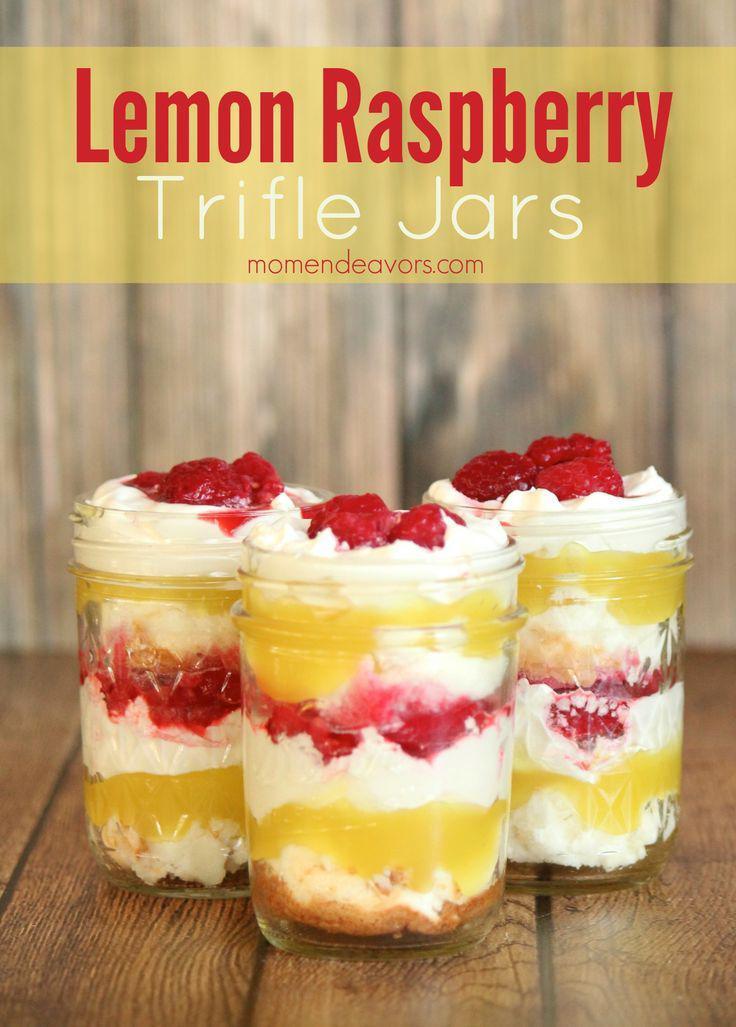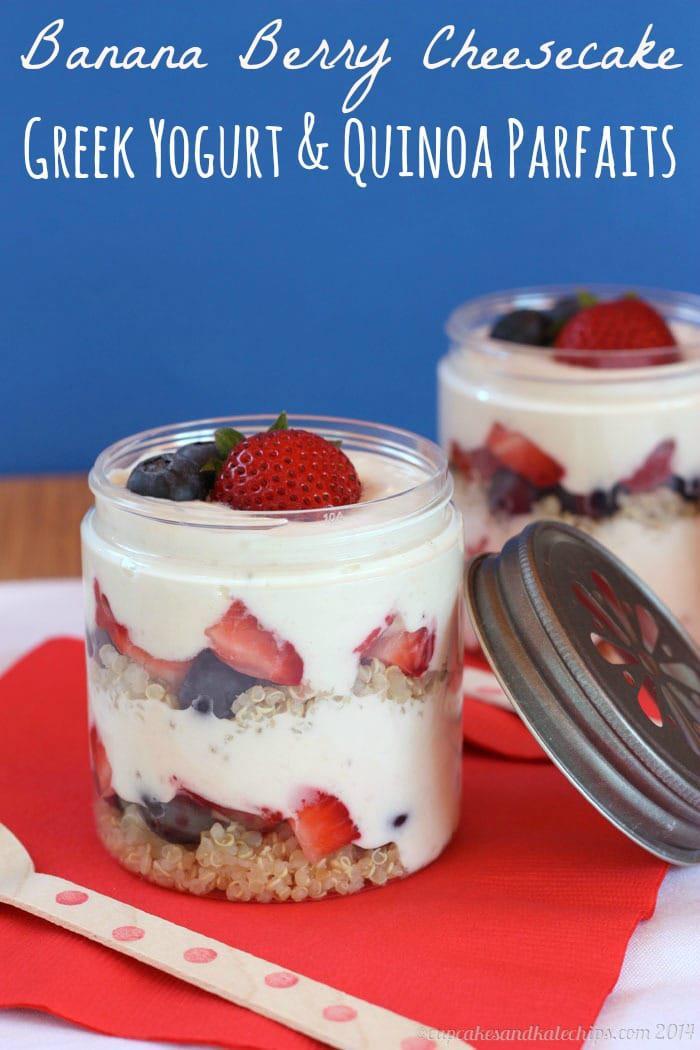The first image is the image on the left, the second image is the image on the right. Evaluate the accuracy of this statement regarding the images: "There is exactly one container in the image on the right.". Is it true? Answer yes or no. No. 